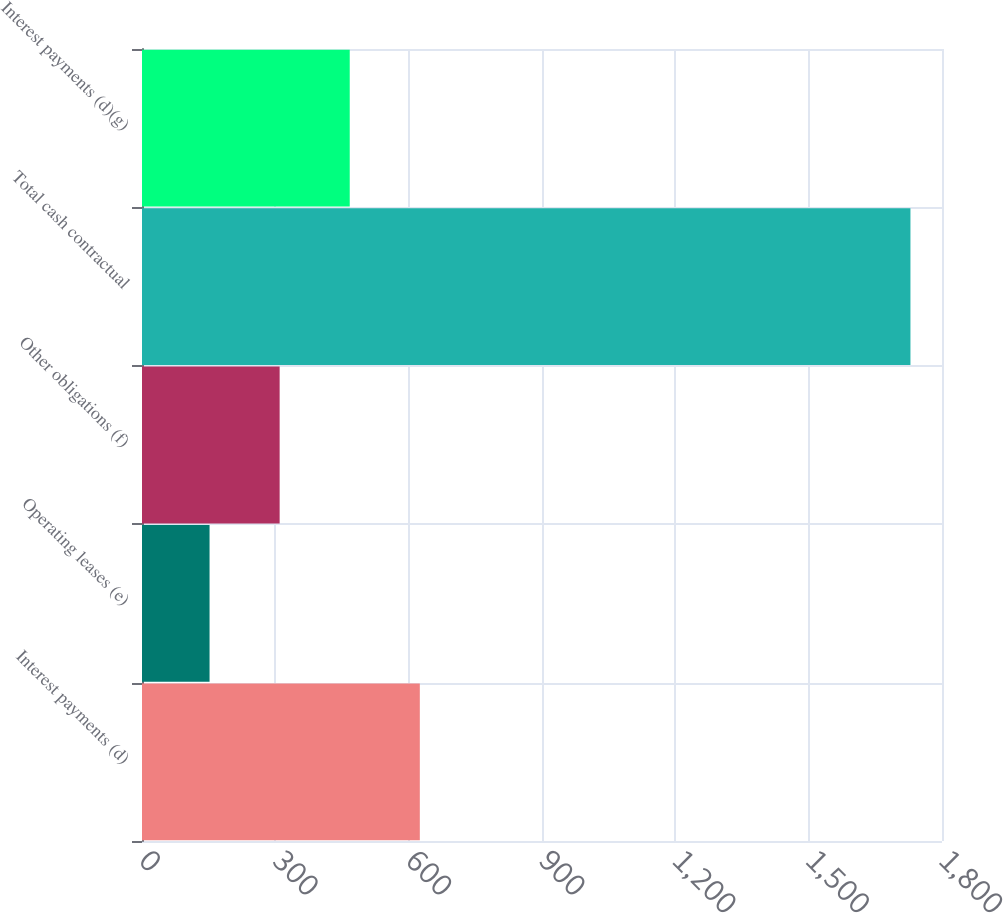Convert chart. <chart><loc_0><loc_0><loc_500><loc_500><bar_chart><fcel>Interest payments (d)<fcel>Operating leases (e)<fcel>Other obligations (f)<fcel>Total cash contractual<fcel>Interest payments (d)(g)<nl><fcel>625.1<fcel>152<fcel>309.7<fcel>1729<fcel>467.4<nl></chart> 